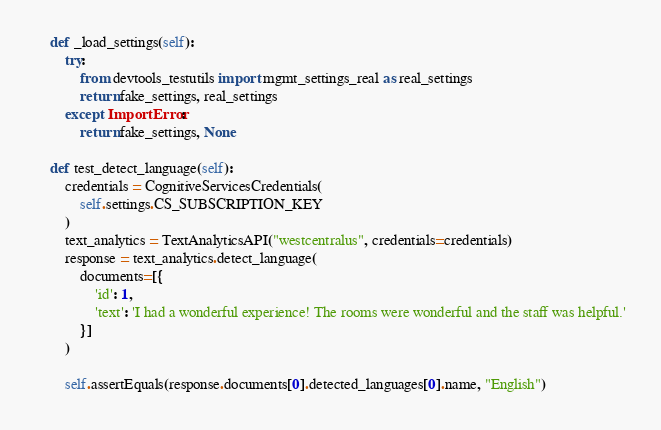<code> <loc_0><loc_0><loc_500><loc_500><_Python_>    def _load_settings(self):
        try:
            from devtools_testutils import mgmt_settings_real as real_settings
            return fake_settings, real_settings
        except ImportError:
            return fake_settings, None

    def test_detect_language(self):
        credentials = CognitiveServicesCredentials(
            self.settings.CS_SUBSCRIPTION_KEY
        )
        text_analytics = TextAnalyticsAPI("westcentralus", credentials=credentials)
        response = text_analytics.detect_language(
            documents=[{
                'id': 1,
                'text': 'I had a wonderful experience! The rooms were wonderful and the staff was helpful.'
            }]
        )

        self.assertEquals(response.documents[0].detected_languages[0].name, "English")


</code> 